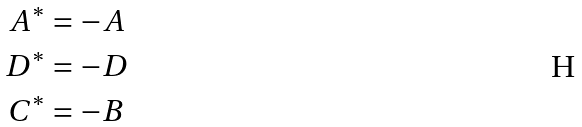<formula> <loc_0><loc_0><loc_500><loc_500>A ^ { * } & = - A \\ D ^ { * } & = - D \\ C ^ { * } & = - B</formula> 